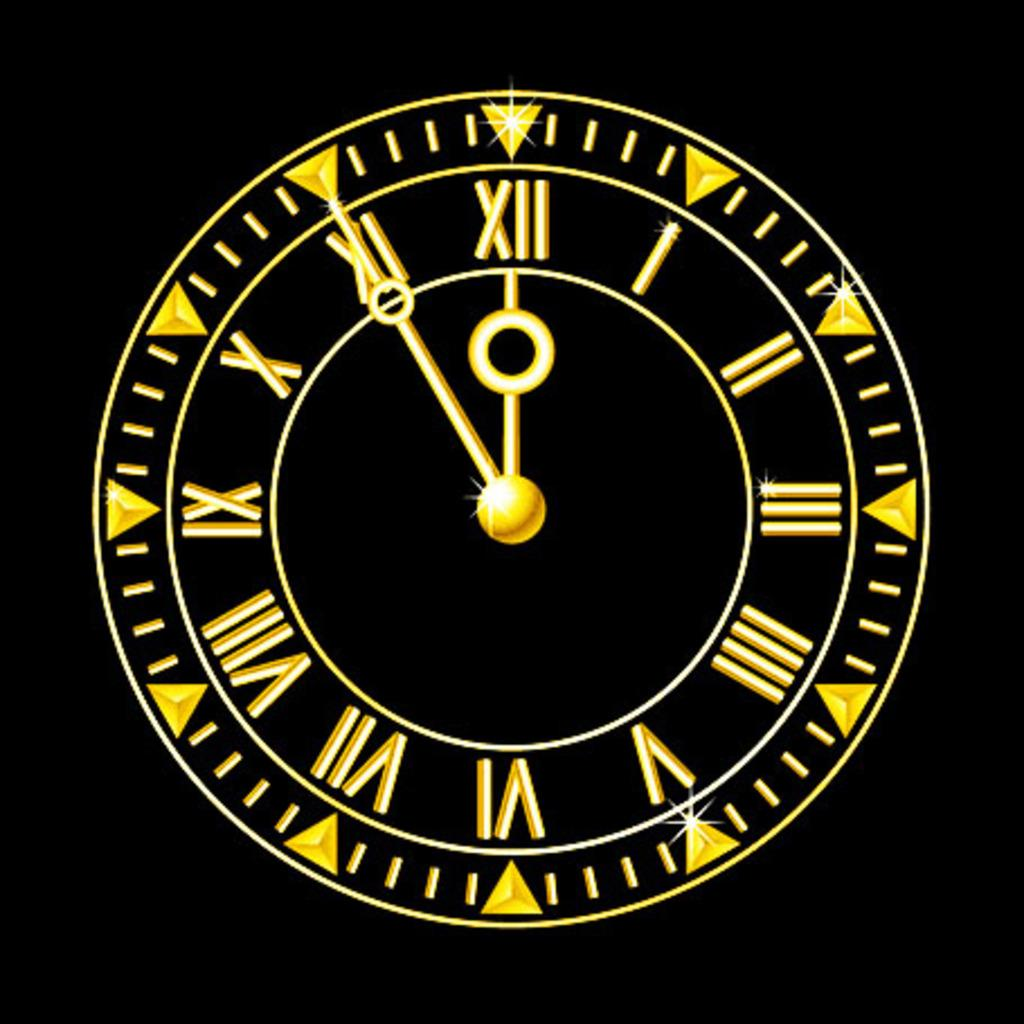What object in the image displays the time? There is a clock in the image that displays the time. How are the numbers on the clock represented? The clock has roman numbers. What are the two additional hands on the clock for? The clock has a seconds hand and a minute hand. What color is the background of the image? The background of the image is black. Where is the rose located in the image? There is no rose present in the image. What is the lock used for in the image? There is no lock present in the image. 